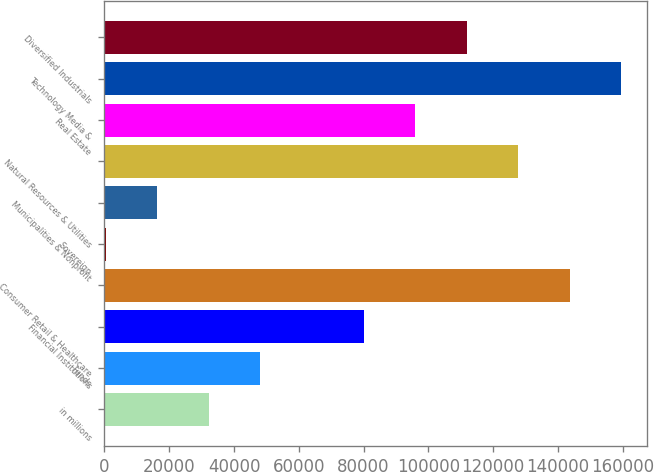<chart> <loc_0><loc_0><loc_500><loc_500><bar_chart><fcel>in millions<fcel>Funds<fcel>Financial Institutions<fcel>Consumer Retail & Healthcare<fcel>Sovereign<fcel>Municipalities & Nonprofit<fcel>Natural Resources & Utilities<fcel>Real Estate<fcel>Technology Media &<fcel>Diversified Industrials<nl><fcel>32255.6<fcel>48173.9<fcel>80010.5<fcel>143684<fcel>419<fcel>16337.3<fcel>127765<fcel>95928.8<fcel>159602<fcel>111847<nl></chart> 